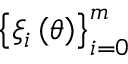<formula> <loc_0><loc_0><loc_500><loc_500>\left \{ \xi _ { i } \left ( \theta \right ) \right \} _ { i = 0 } ^ { m }</formula> 